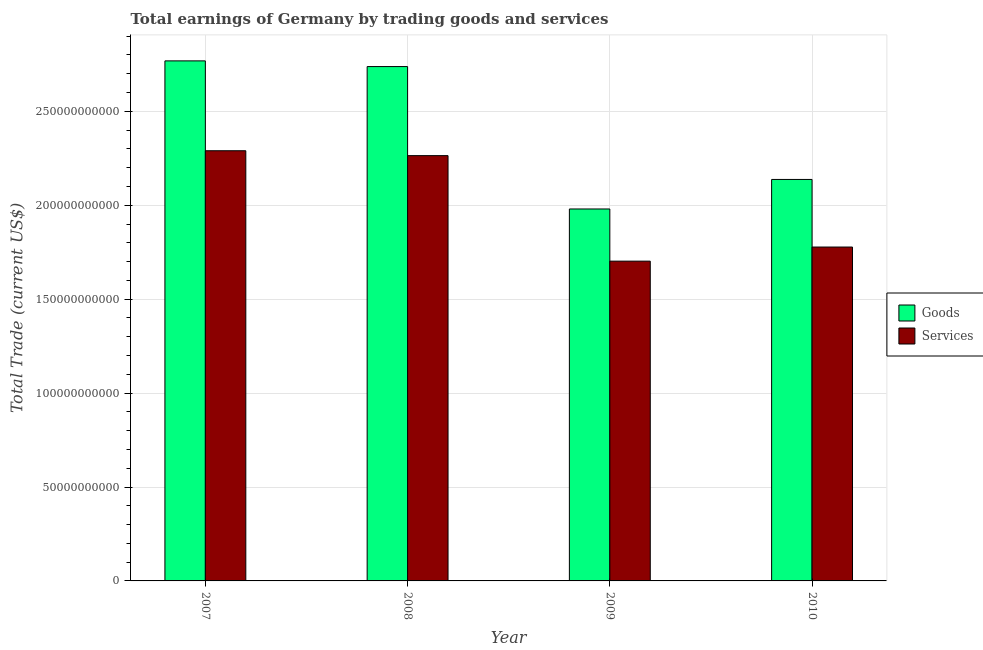How many different coloured bars are there?
Ensure brevity in your answer.  2. Are the number of bars on each tick of the X-axis equal?
Provide a succinct answer. Yes. How many bars are there on the 4th tick from the right?
Provide a short and direct response. 2. What is the amount earned by trading goods in 2009?
Keep it short and to the point. 1.98e+11. Across all years, what is the maximum amount earned by trading services?
Provide a short and direct response. 2.29e+11. Across all years, what is the minimum amount earned by trading goods?
Provide a short and direct response. 1.98e+11. In which year was the amount earned by trading goods maximum?
Your answer should be compact. 2007. What is the total amount earned by trading services in the graph?
Your answer should be very brief. 8.03e+11. What is the difference between the amount earned by trading services in 2009 and that in 2010?
Give a very brief answer. -7.52e+09. What is the difference between the amount earned by trading services in 2008 and the amount earned by trading goods in 2007?
Provide a short and direct response. -2.60e+09. What is the average amount earned by trading services per year?
Your response must be concise. 2.01e+11. In how many years, is the amount earned by trading services greater than 120000000000 US$?
Offer a very short reply. 4. What is the ratio of the amount earned by trading services in 2009 to that in 2010?
Make the answer very short. 0.96. What is the difference between the highest and the second highest amount earned by trading goods?
Provide a succinct answer. 3.03e+09. What is the difference between the highest and the lowest amount earned by trading services?
Provide a succinct answer. 5.88e+1. In how many years, is the amount earned by trading services greater than the average amount earned by trading services taken over all years?
Give a very brief answer. 2. What does the 2nd bar from the left in 2009 represents?
Ensure brevity in your answer.  Services. What does the 2nd bar from the right in 2010 represents?
Offer a terse response. Goods. Are all the bars in the graph horizontal?
Keep it short and to the point. No. How many years are there in the graph?
Ensure brevity in your answer.  4. Are the values on the major ticks of Y-axis written in scientific E-notation?
Offer a terse response. No. Does the graph contain any zero values?
Ensure brevity in your answer.  No. Does the graph contain grids?
Provide a succinct answer. Yes. Where does the legend appear in the graph?
Your response must be concise. Center right. How many legend labels are there?
Offer a terse response. 2. What is the title of the graph?
Offer a very short reply. Total earnings of Germany by trading goods and services. What is the label or title of the Y-axis?
Your response must be concise. Total Trade (current US$). What is the Total Trade (current US$) of Goods in 2007?
Provide a succinct answer. 2.77e+11. What is the Total Trade (current US$) of Services in 2007?
Your answer should be compact. 2.29e+11. What is the Total Trade (current US$) in Goods in 2008?
Make the answer very short. 2.74e+11. What is the Total Trade (current US$) of Services in 2008?
Provide a short and direct response. 2.26e+11. What is the Total Trade (current US$) in Goods in 2009?
Offer a terse response. 1.98e+11. What is the Total Trade (current US$) of Services in 2009?
Provide a succinct answer. 1.70e+11. What is the Total Trade (current US$) of Goods in 2010?
Make the answer very short. 2.14e+11. What is the Total Trade (current US$) in Services in 2010?
Keep it short and to the point. 1.78e+11. Across all years, what is the maximum Total Trade (current US$) of Goods?
Provide a succinct answer. 2.77e+11. Across all years, what is the maximum Total Trade (current US$) of Services?
Offer a very short reply. 2.29e+11. Across all years, what is the minimum Total Trade (current US$) in Goods?
Give a very brief answer. 1.98e+11. Across all years, what is the minimum Total Trade (current US$) of Services?
Make the answer very short. 1.70e+11. What is the total Total Trade (current US$) in Goods in the graph?
Keep it short and to the point. 9.62e+11. What is the total Total Trade (current US$) in Services in the graph?
Ensure brevity in your answer.  8.03e+11. What is the difference between the Total Trade (current US$) of Goods in 2007 and that in 2008?
Offer a terse response. 3.03e+09. What is the difference between the Total Trade (current US$) in Services in 2007 and that in 2008?
Your answer should be very brief. 2.60e+09. What is the difference between the Total Trade (current US$) of Goods in 2007 and that in 2009?
Give a very brief answer. 7.88e+1. What is the difference between the Total Trade (current US$) of Services in 2007 and that in 2009?
Your answer should be very brief. 5.88e+1. What is the difference between the Total Trade (current US$) of Goods in 2007 and that in 2010?
Offer a terse response. 6.31e+1. What is the difference between the Total Trade (current US$) of Services in 2007 and that in 2010?
Your answer should be very brief. 5.13e+1. What is the difference between the Total Trade (current US$) in Goods in 2008 and that in 2009?
Give a very brief answer. 7.58e+1. What is the difference between the Total Trade (current US$) in Services in 2008 and that in 2009?
Provide a short and direct response. 5.62e+1. What is the difference between the Total Trade (current US$) in Goods in 2008 and that in 2010?
Keep it short and to the point. 6.01e+1. What is the difference between the Total Trade (current US$) in Services in 2008 and that in 2010?
Your answer should be very brief. 4.87e+1. What is the difference between the Total Trade (current US$) in Goods in 2009 and that in 2010?
Give a very brief answer. -1.57e+1. What is the difference between the Total Trade (current US$) in Services in 2009 and that in 2010?
Provide a succinct answer. -7.52e+09. What is the difference between the Total Trade (current US$) of Goods in 2007 and the Total Trade (current US$) of Services in 2008?
Your answer should be very brief. 5.04e+1. What is the difference between the Total Trade (current US$) of Goods in 2007 and the Total Trade (current US$) of Services in 2009?
Keep it short and to the point. 1.07e+11. What is the difference between the Total Trade (current US$) of Goods in 2007 and the Total Trade (current US$) of Services in 2010?
Ensure brevity in your answer.  9.91e+1. What is the difference between the Total Trade (current US$) in Goods in 2008 and the Total Trade (current US$) in Services in 2009?
Offer a very short reply. 1.04e+11. What is the difference between the Total Trade (current US$) of Goods in 2008 and the Total Trade (current US$) of Services in 2010?
Provide a short and direct response. 9.61e+1. What is the difference between the Total Trade (current US$) in Goods in 2009 and the Total Trade (current US$) in Services in 2010?
Provide a short and direct response. 2.03e+1. What is the average Total Trade (current US$) of Goods per year?
Keep it short and to the point. 2.41e+11. What is the average Total Trade (current US$) in Services per year?
Provide a short and direct response. 2.01e+11. In the year 2007, what is the difference between the Total Trade (current US$) of Goods and Total Trade (current US$) of Services?
Offer a terse response. 4.78e+1. In the year 2008, what is the difference between the Total Trade (current US$) in Goods and Total Trade (current US$) in Services?
Give a very brief answer. 4.74e+1. In the year 2009, what is the difference between the Total Trade (current US$) in Goods and Total Trade (current US$) in Services?
Give a very brief answer. 2.78e+1. In the year 2010, what is the difference between the Total Trade (current US$) in Goods and Total Trade (current US$) in Services?
Your response must be concise. 3.60e+1. What is the ratio of the Total Trade (current US$) in Goods in 2007 to that in 2008?
Keep it short and to the point. 1.01. What is the ratio of the Total Trade (current US$) in Services in 2007 to that in 2008?
Offer a terse response. 1.01. What is the ratio of the Total Trade (current US$) of Goods in 2007 to that in 2009?
Offer a terse response. 1.4. What is the ratio of the Total Trade (current US$) of Services in 2007 to that in 2009?
Your answer should be very brief. 1.35. What is the ratio of the Total Trade (current US$) in Goods in 2007 to that in 2010?
Your answer should be very brief. 1.3. What is the ratio of the Total Trade (current US$) of Services in 2007 to that in 2010?
Provide a succinct answer. 1.29. What is the ratio of the Total Trade (current US$) of Goods in 2008 to that in 2009?
Your answer should be very brief. 1.38. What is the ratio of the Total Trade (current US$) in Services in 2008 to that in 2009?
Your answer should be very brief. 1.33. What is the ratio of the Total Trade (current US$) in Goods in 2008 to that in 2010?
Your response must be concise. 1.28. What is the ratio of the Total Trade (current US$) of Services in 2008 to that in 2010?
Ensure brevity in your answer.  1.27. What is the ratio of the Total Trade (current US$) in Goods in 2009 to that in 2010?
Provide a succinct answer. 0.93. What is the ratio of the Total Trade (current US$) in Services in 2009 to that in 2010?
Provide a short and direct response. 0.96. What is the difference between the highest and the second highest Total Trade (current US$) of Goods?
Keep it short and to the point. 3.03e+09. What is the difference between the highest and the second highest Total Trade (current US$) of Services?
Give a very brief answer. 2.60e+09. What is the difference between the highest and the lowest Total Trade (current US$) of Goods?
Make the answer very short. 7.88e+1. What is the difference between the highest and the lowest Total Trade (current US$) of Services?
Give a very brief answer. 5.88e+1. 